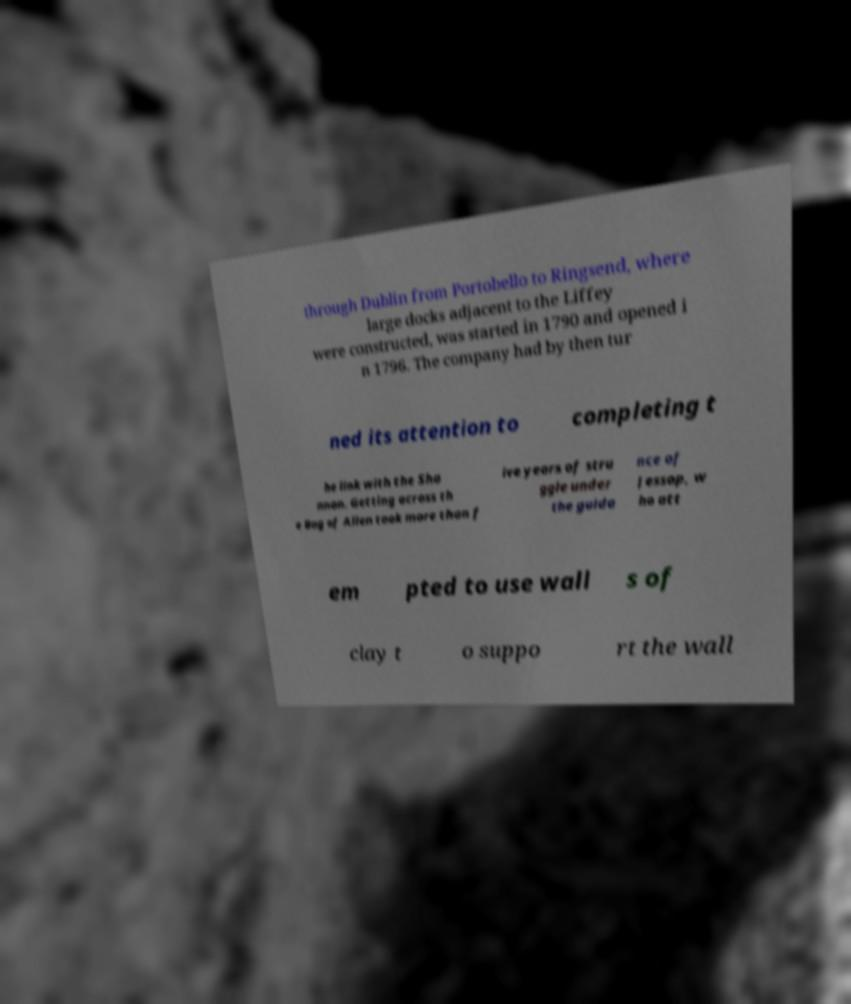What messages or text are displayed in this image? I need them in a readable, typed format. through Dublin from Portobello to Ringsend, where large docks adjacent to the Liffey were constructed, was started in 1790 and opened i n 1796. The company had by then tur ned its attention to completing t he link with the Sha nnon. Getting across th e Bog of Allen took more than f ive years of stru ggle under the guida nce of Jessop, w ho att em pted to use wall s of clay t o suppo rt the wall 